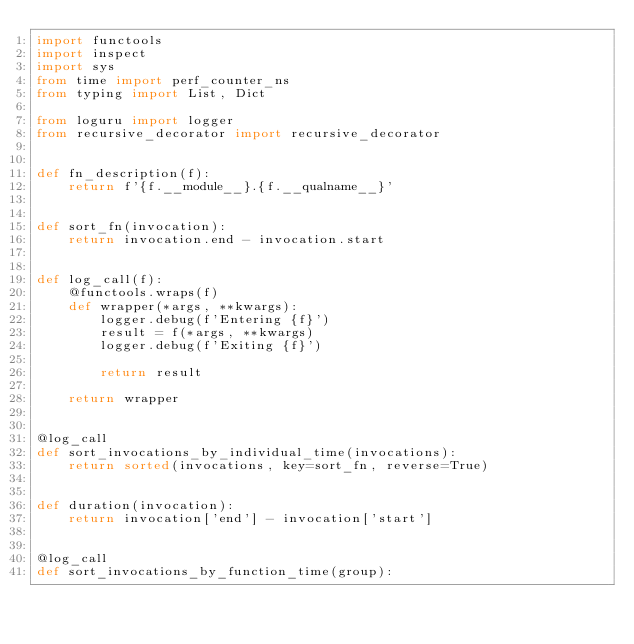<code> <loc_0><loc_0><loc_500><loc_500><_Python_>import functools
import inspect
import sys
from time import perf_counter_ns
from typing import List, Dict

from loguru import logger
from recursive_decorator import recursive_decorator


def fn_description(f):
    return f'{f.__module__}.{f.__qualname__}'


def sort_fn(invocation):
    return invocation.end - invocation.start


def log_call(f):
    @functools.wraps(f)
    def wrapper(*args, **kwargs):
        logger.debug(f'Entering {f}')
        result = f(*args, **kwargs)
        logger.debug(f'Exiting {f}')

        return result

    return wrapper


@log_call
def sort_invocations_by_individual_time(invocations):
    return sorted(invocations, key=sort_fn, reverse=True)


def duration(invocation):
    return invocation['end'] - invocation['start']


@log_call
def sort_invocations_by_function_time(group):</code> 